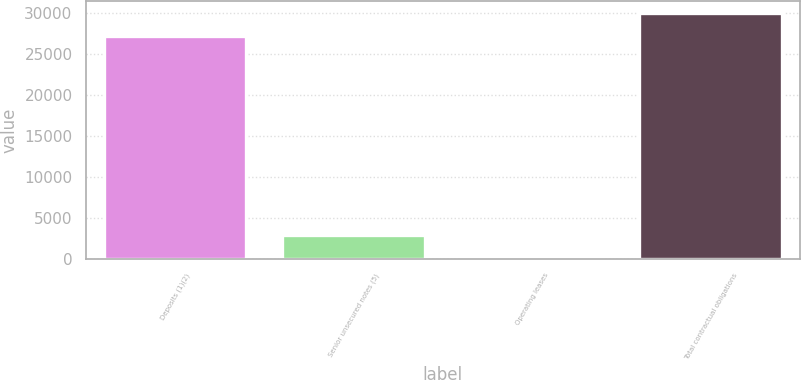<chart> <loc_0><loc_0><loc_500><loc_500><bar_chart><fcel>Deposits (1)(2)<fcel>Senior unsecured notes (5)<fcel>Operating leases<fcel>Total contractual obligations<nl><fcel>27187<fcel>2871.4<fcel>35<fcel>30023.4<nl></chart> 